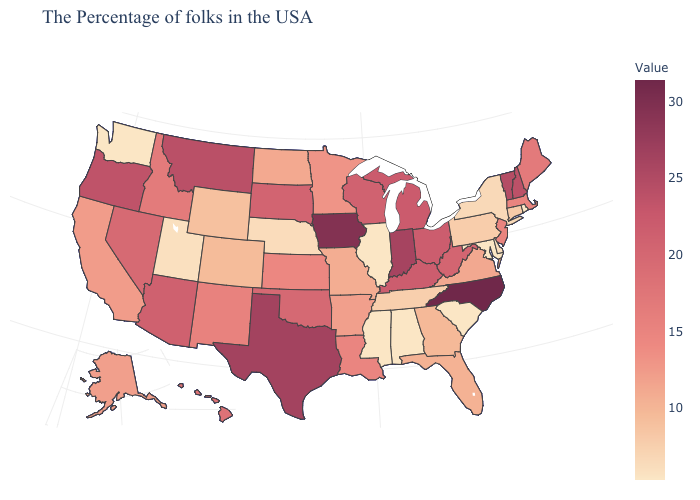Is the legend a continuous bar?
Quick response, please. Yes. Among the states that border Arizona , which have the lowest value?
Give a very brief answer. Utah. Does Colorado have a higher value than New York?
Write a very short answer. Yes. Does Minnesota have a lower value than Nevada?
Write a very short answer. Yes. Which states have the highest value in the USA?
Give a very brief answer. North Carolina. 